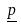<formula> <loc_0><loc_0><loc_500><loc_500>\underline { p }</formula> 